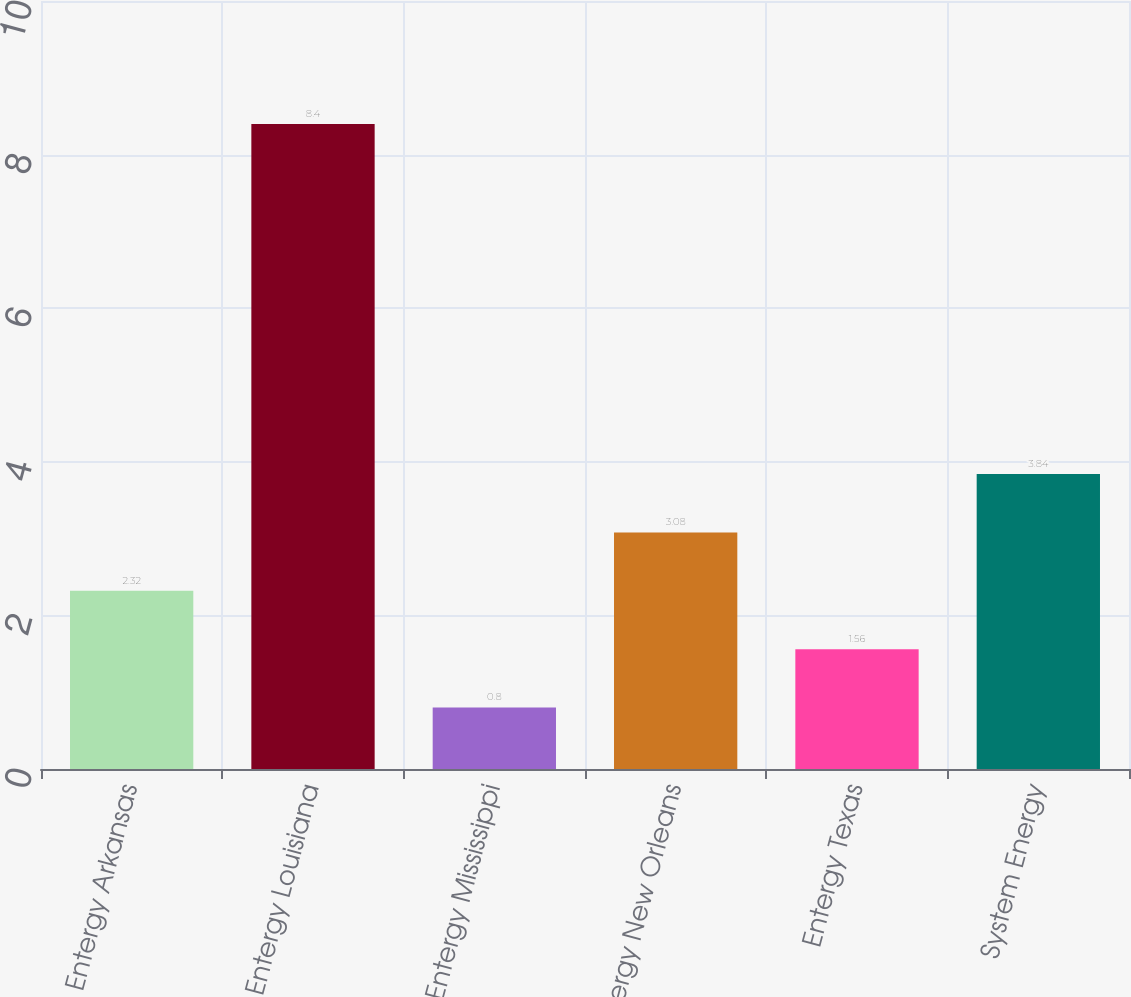Convert chart to OTSL. <chart><loc_0><loc_0><loc_500><loc_500><bar_chart><fcel>Entergy Arkansas<fcel>Entergy Louisiana<fcel>Entergy Mississippi<fcel>Entergy New Orleans<fcel>Entergy Texas<fcel>System Energy<nl><fcel>2.32<fcel>8.4<fcel>0.8<fcel>3.08<fcel>1.56<fcel>3.84<nl></chart> 